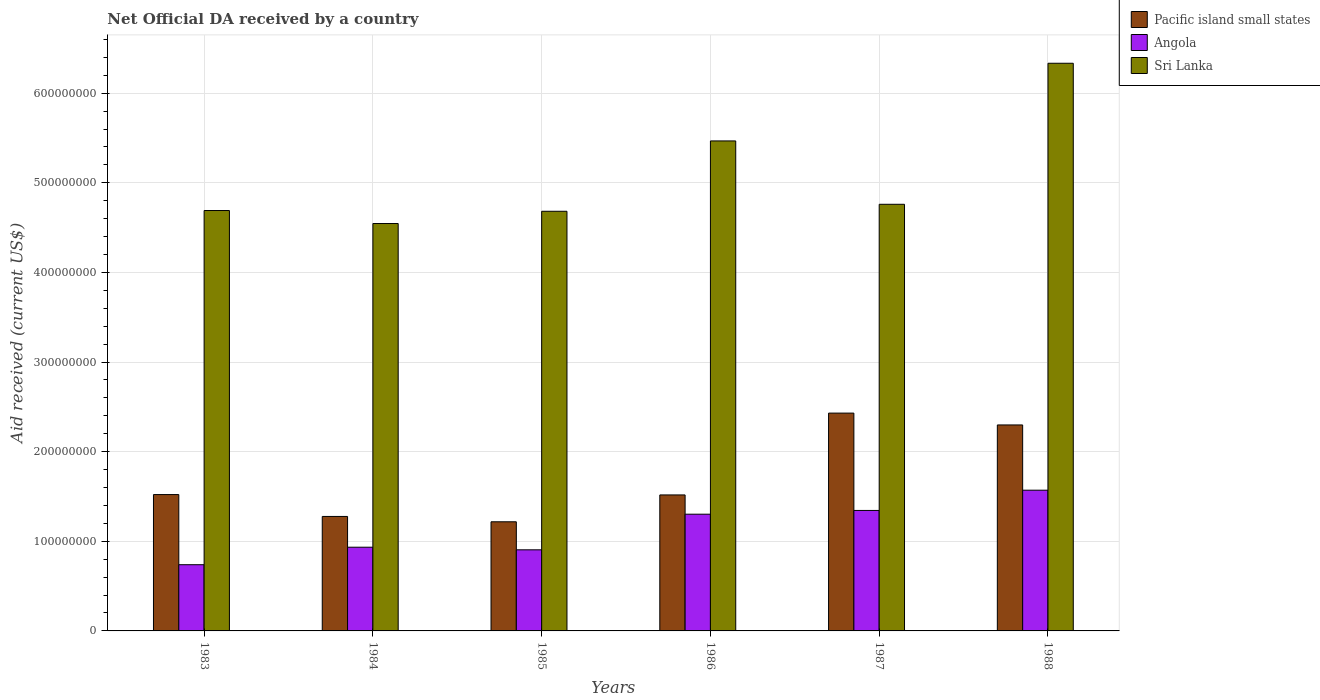How many groups of bars are there?
Ensure brevity in your answer.  6. Are the number of bars per tick equal to the number of legend labels?
Your answer should be very brief. Yes. Are the number of bars on each tick of the X-axis equal?
Provide a short and direct response. Yes. How many bars are there on the 3rd tick from the right?
Provide a succinct answer. 3. What is the label of the 2nd group of bars from the left?
Your answer should be very brief. 1984. What is the net official development assistance aid received in Angola in 1983?
Your response must be concise. 7.39e+07. Across all years, what is the maximum net official development assistance aid received in Angola?
Provide a succinct answer. 1.57e+08. Across all years, what is the minimum net official development assistance aid received in Sri Lanka?
Provide a succinct answer. 4.55e+08. In which year was the net official development assistance aid received in Sri Lanka minimum?
Offer a terse response. 1984. What is the total net official development assistance aid received in Sri Lanka in the graph?
Make the answer very short. 3.05e+09. What is the difference between the net official development assistance aid received in Sri Lanka in 1984 and that in 1987?
Give a very brief answer. -2.15e+07. What is the difference between the net official development assistance aid received in Sri Lanka in 1983 and the net official development assistance aid received in Pacific island small states in 1984?
Give a very brief answer. 3.41e+08. What is the average net official development assistance aid received in Angola per year?
Give a very brief answer. 1.13e+08. In the year 1985, what is the difference between the net official development assistance aid received in Pacific island small states and net official development assistance aid received in Angola?
Offer a terse response. 3.13e+07. In how many years, is the net official development assistance aid received in Angola greater than 300000000 US$?
Give a very brief answer. 0. What is the ratio of the net official development assistance aid received in Angola in 1985 to that in 1987?
Provide a succinct answer. 0.67. What is the difference between the highest and the second highest net official development assistance aid received in Angola?
Your answer should be very brief. 2.26e+07. What is the difference between the highest and the lowest net official development assistance aid received in Angola?
Your response must be concise. 8.32e+07. What does the 1st bar from the left in 1984 represents?
Your response must be concise. Pacific island small states. What does the 2nd bar from the right in 1984 represents?
Your answer should be very brief. Angola. Is it the case that in every year, the sum of the net official development assistance aid received in Angola and net official development assistance aid received in Sri Lanka is greater than the net official development assistance aid received in Pacific island small states?
Provide a succinct answer. Yes. Are all the bars in the graph horizontal?
Your response must be concise. No. How many years are there in the graph?
Keep it short and to the point. 6. What is the difference between two consecutive major ticks on the Y-axis?
Offer a terse response. 1.00e+08. Are the values on the major ticks of Y-axis written in scientific E-notation?
Your response must be concise. No. Does the graph contain grids?
Provide a short and direct response. Yes. How are the legend labels stacked?
Your answer should be compact. Vertical. What is the title of the graph?
Your response must be concise. Net Official DA received by a country. Does "South Asia" appear as one of the legend labels in the graph?
Provide a succinct answer. No. What is the label or title of the Y-axis?
Keep it short and to the point. Aid received (current US$). What is the Aid received (current US$) in Pacific island small states in 1983?
Offer a very short reply. 1.52e+08. What is the Aid received (current US$) of Angola in 1983?
Provide a short and direct response. 7.39e+07. What is the Aid received (current US$) in Sri Lanka in 1983?
Provide a short and direct response. 4.69e+08. What is the Aid received (current US$) in Pacific island small states in 1984?
Your answer should be very brief. 1.28e+08. What is the Aid received (current US$) of Angola in 1984?
Ensure brevity in your answer.  9.34e+07. What is the Aid received (current US$) in Sri Lanka in 1984?
Keep it short and to the point. 4.55e+08. What is the Aid received (current US$) in Pacific island small states in 1985?
Your response must be concise. 1.22e+08. What is the Aid received (current US$) in Angola in 1985?
Your answer should be compact. 9.05e+07. What is the Aid received (current US$) in Sri Lanka in 1985?
Ensure brevity in your answer.  4.68e+08. What is the Aid received (current US$) of Pacific island small states in 1986?
Offer a very short reply. 1.52e+08. What is the Aid received (current US$) in Angola in 1986?
Provide a succinct answer. 1.30e+08. What is the Aid received (current US$) of Sri Lanka in 1986?
Provide a succinct answer. 5.47e+08. What is the Aid received (current US$) of Pacific island small states in 1987?
Offer a terse response. 2.43e+08. What is the Aid received (current US$) in Angola in 1987?
Make the answer very short. 1.34e+08. What is the Aid received (current US$) of Sri Lanka in 1987?
Keep it short and to the point. 4.76e+08. What is the Aid received (current US$) in Pacific island small states in 1988?
Offer a terse response. 2.30e+08. What is the Aid received (current US$) of Angola in 1988?
Keep it short and to the point. 1.57e+08. What is the Aid received (current US$) in Sri Lanka in 1988?
Make the answer very short. 6.33e+08. Across all years, what is the maximum Aid received (current US$) of Pacific island small states?
Ensure brevity in your answer.  2.43e+08. Across all years, what is the maximum Aid received (current US$) in Angola?
Give a very brief answer. 1.57e+08. Across all years, what is the maximum Aid received (current US$) of Sri Lanka?
Keep it short and to the point. 6.33e+08. Across all years, what is the minimum Aid received (current US$) in Pacific island small states?
Offer a very short reply. 1.22e+08. Across all years, what is the minimum Aid received (current US$) in Angola?
Provide a short and direct response. 7.39e+07. Across all years, what is the minimum Aid received (current US$) of Sri Lanka?
Your answer should be compact. 4.55e+08. What is the total Aid received (current US$) of Pacific island small states in the graph?
Make the answer very short. 1.03e+09. What is the total Aid received (current US$) in Angola in the graph?
Offer a very short reply. 6.79e+08. What is the total Aid received (current US$) in Sri Lanka in the graph?
Offer a very short reply. 3.05e+09. What is the difference between the Aid received (current US$) of Pacific island small states in 1983 and that in 1984?
Ensure brevity in your answer.  2.44e+07. What is the difference between the Aid received (current US$) of Angola in 1983 and that in 1984?
Provide a short and direct response. -1.95e+07. What is the difference between the Aid received (current US$) in Sri Lanka in 1983 and that in 1984?
Provide a succinct answer. 1.45e+07. What is the difference between the Aid received (current US$) of Pacific island small states in 1983 and that in 1985?
Provide a short and direct response. 3.04e+07. What is the difference between the Aid received (current US$) in Angola in 1983 and that in 1985?
Give a very brief answer. -1.66e+07. What is the difference between the Aid received (current US$) of Sri Lanka in 1983 and that in 1985?
Give a very brief answer. 8.20e+05. What is the difference between the Aid received (current US$) of Angola in 1983 and that in 1986?
Your answer should be very brief. -5.64e+07. What is the difference between the Aid received (current US$) in Sri Lanka in 1983 and that in 1986?
Offer a terse response. -7.77e+07. What is the difference between the Aid received (current US$) in Pacific island small states in 1983 and that in 1987?
Your response must be concise. -9.09e+07. What is the difference between the Aid received (current US$) of Angola in 1983 and that in 1987?
Provide a succinct answer. -6.06e+07. What is the difference between the Aid received (current US$) in Sri Lanka in 1983 and that in 1987?
Offer a terse response. -6.97e+06. What is the difference between the Aid received (current US$) of Pacific island small states in 1983 and that in 1988?
Offer a very short reply. -7.77e+07. What is the difference between the Aid received (current US$) in Angola in 1983 and that in 1988?
Provide a succinct answer. -8.32e+07. What is the difference between the Aid received (current US$) of Sri Lanka in 1983 and that in 1988?
Your response must be concise. -1.64e+08. What is the difference between the Aid received (current US$) of Pacific island small states in 1984 and that in 1985?
Give a very brief answer. 5.96e+06. What is the difference between the Aid received (current US$) of Angola in 1984 and that in 1985?
Keep it short and to the point. 2.92e+06. What is the difference between the Aid received (current US$) in Sri Lanka in 1984 and that in 1985?
Give a very brief answer. -1.37e+07. What is the difference between the Aid received (current US$) of Pacific island small states in 1984 and that in 1986?
Your answer should be compact. -2.40e+07. What is the difference between the Aid received (current US$) in Angola in 1984 and that in 1986?
Offer a very short reply. -3.68e+07. What is the difference between the Aid received (current US$) in Sri Lanka in 1984 and that in 1986?
Your answer should be compact. -9.22e+07. What is the difference between the Aid received (current US$) in Pacific island small states in 1984 and that in 1987?
Give a very brief answer. -1.15e+08. What is the difference between the Aid received (current US$) in Angola in 1984 and that in 1987?
Your answer should be compact. -4.10e+07. What is the difference between the Aid received (current US$) in Sri Lanka in 1984 and that in 1987?
Keep it short and to the point. -2.15e+07. What is the difference between the Aid received (current US$) of Pacific island small states in 1984 and that in 1988?
Your answer should be very brief. -1.02e+08. What is the difference between the Aid received (current US$) in Angola in 1984 and that in 1988?
Your answer should be very brief. -6.36e+07. What is the difference between the Aid received (current US$) in Sri Lanka in 1984 and that in 1988?
Your answer should be very brief. -1.79e+08. What is the difference between the Aid received (current US$) in Pacific island small states in 1985 and that in 1986?
Offer a very short reply. -3.00e+07. What is the difference between the Aid received (current US$) of Angola in 1985 and that in 1986?
Ensure brevity in your answer.  -3.98e+07. What is the difference between the Aid received (current US$) of Sri Lanka in 1985 and that in 1986?
Give a very brief answer. -7.85e+07. What is the difference between the Aid received (current US$) in Pacific island small states in 1985 and that in 1987?
Offer a terse response. -1.21e+08. What is the difference between the Aid received (current US$) of Angola in 1985 and that in 1987?
Keep it short and to the point. -4.39e+07. What is the difference between the Aid received (current US$) in Sri Lanka in 1985 and that in 1987?
Make the answer very short. -7.79e+06. What is the difference between the Aid received (current US$) of Pacific island small states in 1985 and that in 1988?
Ensure brevity in your answer.  -1.08e+08. What is the difference between the Aid received (current US$) of Angola in 1985 and that in 1988?
Offer a terse response. -6.65e+07. What is the difference between the Aid received (current US$) in Sri Lanka in 1985 and that in 1988?
Keep it short and to the point. -1.65e+08. What is the difference between the Aid received (current US$) of Pacific island small states in 1986 and that in 1987?
Provide a short and direct response. -9.13e+07. What is the difference between the Aid received (current US$) in Angola in 1986 and that in 1987?
Your answer should be compact. -4.18e+06. What is the difference between the Aid received (current US$) of Sri Lanka in 1986 and that in 1987?
Ensure brevity in your answer.  7.07e+07. What is the difference between the Aid received (current US$) of Pacific island small states in 1986 and that in 1988?
Ensure brevity in your answer.  -7.81e+07. What is the difference between the Aid received (current US$) in Angola in 1986 and that in 1988?
Provide a short and direct response. -2.68e+07. What is the difference between the Aid received (current US$) of Sri Lanka in 1986 and that in 1988?
Offer a very short reply. -8.67e+07. What is the difference between the Aid received (current US$) of Pacific island small states in 1987 and that in 1988?
Provide a short and direct response. 1.32e+07. What is the difference between the Aid received (current US$) of Angola in 1987 and that in 1988?
Your answer should be compact. -2.26e+07. What is the difference between the Aid received (current US$) of Sri Lanka in 1987 and that in 1988?
Give a very brief answer. -1.57e+08. What is the difference between the Aid received (current US$) of Pacific island small states in 1983 and the Aid received (current US$) of Angola in 1984?
Your response must be concise. 5.87e+07. What is the difference between the Aid received (current US$) in Pacific island small states in 1983 and the Aid received (current US$) in Sri Lanka in 1984?
Give a very brief answer. -3.02e+08. What is the difference between the Aid received (current US$) in Angola in 1983 and the Aid received (current US$) in Sri Lanka in 1984?
Ensure brevity in your answer.  -3.81e+08. What is the difference between the Aid received (current US$) of Pacific island small states in 1983 and the Aid received (current US$) of Angola in 1985?
Make the answer very short. 6.17e+07. What is the difference between the Aid received (current US$) in Pacific island small states in 1983 and the Aid received (current US$) in Sri Lanka in 1985?
Keep it short and to the point. -3.16e+08. What is the difference between the Aid received (current US$) in Angola in 1983 and the Aid received (current US$) in Sri Lanka in 1985?
Provide a succinct answer. -3.94e+08. What is the difference between the Aid received (current US$) in Pacific island small states in 1983 and the Aid received (current US$) in Angola in 1986?
Your answer should be compact. 2.19e+07. What is the difference between the Aid received (current US$) of Pacific island small states in 1983 and the Aid received (current US$) of Sri Lanka in 1986?
Your answer should be very brief. -3.95e+08. What is the difference between the Aid received (current US$) of Angola in 1983 and the Aid received (current US$) of Sri Lanka in 1986?
Offer a very short reply. -4.73e+08. What is the difference between the Aid received (current US$) of Pacific island small states in 1983 and the Aid received (current US$) of Angola in 1987?
Offer a terse response. 1.77e+07. What is the difference between the Aid received (current US$) of Pacific island small states in 1983 and the Aid received (current US$) of Sri Lanka in 1987?
Provide a succinct answer. -3.24e+08. What is the difference between the Aid received (current US$) of Angola in 1983 and the Aid received (current US$) of Sri Lanka in 1987?
Keep it short and to the point. -4.02e+08. What is the difference between the Aid received (current US$) in Pacific island small states in 1983 and the Aid received (current US$) in Angola in 1988?
Offer a very short reply. -4.88e+06. What is the difference between the Aid received (current US$) of Pacific island small states in 1983 and the Aid received (current US$) of Sri Lanka in 1988?
Ensure brevity in your answer.  -4.81e+08. What is the difference between the Aid received (current US$) in Angola in 1983 and the Aid received (current US$) in Sri Lanka in 1988?
Provide a succinct answer. -5.60e+08. What is the difference between the Aid received (current US$) of Pacific island small states in 1984 and the Aid received (current US$) of Angola in 1985?
Provide a succinct answer. 3.72e+07. What is the difference between the Aid received (current US$) of Pacific island small states in 1984 and the Aid received (current US$) of Sri Lanka in 1985?
Offer a terse response. -3.41e+08. What is the difference between the Aid received (current US$) of Angola in 1984 and the Aid received (current US$) of Sri Lanka in 1985?
Give a very brief answer. -3.75e+08. What is the difference between the Aid received (current US$) of Pacific island small states in 1984 and the Aid received (current US$) of Angola in 1986?
Provide a short and direct response. -2.52e+06. What is the difference between the Aid received (current US$) in Pacific island small states in 1984 and the Aid received (current US$) in Sri Lanka in 1986?
Offer a terse response. -4.19e+08. What is the difference between the Aid received (current US$) of Angola in 1984 and the Aid received (current US$) of Sri Lanka in 1986?
Make the answer very short. -4.53e+08. What is the difference between the Aid received (current US$) of Pacific island small states in 1984 and the Aid received (current US$) of Angola in 1987?
Give a very brief answer. -6.70e+06. What is the difference between the Aid received (current US$) of Pacific island small states in 1984 and the Aid received (current US$) of Sri Lanka in 1987?
Offer a very short reply. -3.48e+08. What is the difference between the Aid received (current US$) of Angola in 1984 and the Aid received (current US$) of Sri Lanka in 1987?
Ensure brevity in your answer.  -3.83e+08. What is the difference between the Aid received (current US$) in Pacific island small states in 1984 and the Aid received (current US$) in Angola in 1988?
Provide a succinct answer. -2.93e+07. What is the difference between the Aid received (current US$) in Pacific island small states in 1984 and the Aid received (current US$) in Sri Lanka in 1988?
Ensure brevity in your answer.  -5.06e+08. What is the difference between the Aid received (current US$) of Angola in 1984 and the Aid received (current US$) of Sri Lanka in 1988?
Ensure brevity in your answer.  -5.40e+08. What is the difference between the Aid received (current US$) in Pacific island small states in 1985 and the Aid received (current US$) in Angola in 1986?
Your response must be concise. -8.48e+06. What is the difference between the Aid received (current US$) of Pacific island small states in 1985 and the Aid received (current US$) of Sri Lanka in 1986?
Give a very brief answer. -4.25e+08. What is the difference between the Aid received (current US$) in Angola in 1985 and the Aid received (current US$) in Sri Lanka in 1986?
Make the answer very short. -4.56e+08. What is the difference between the Aid received (current US$) of Pacific island small states in 1985 and the Aid received (current US$) of Angola in 1987?
Your response must be concise. -1.27e+07. What is the difference between the Aid received (current US$) in Pacific island small states in 1985 and the Aid received (current US$) in Sri Lanka in 1987?
Your answer should be compact. -3.54e+08. What is the difference between the Aid received (current US$) in Angola in 1985 and the Aid received (current US$) in Sri Lanka in 1987?
Offer a very short reply. -3.86e+08. What is the difference between the Aid received (current US$) of Pacific island small states in 1985 and the Aid received (current US$) of Angola in 1988?
Give a very brief answer. -3.53e+07. What is the difference between the Aid received (current US$) of Pacific island small states in 1985 and the Aid received (current US$) of Sri Lanka in 1988?
Your response must be concise. -5.12e+08. What is the difference between the Aid received (current US$) of Angola in 1985 and the Aid received (current US$) of Sri Lanka in 1988?
Provide a succinct answer. -5.43e+08. What is the difference between the Aid received (current US$) of Pacific island small states in 1986 and the Aid received (current US$) of Angola in 1987?
Make the answer very short. 1.73e+07. What is the difference between the Aid received (current US$) of Pacific island small states in 1986 and the Aid received (current US$) of Sri Lanka in 1987?
Keep it short and to the point. -3.24e+08. What is the difference between the Aid received (current US$) in Angola in 1986 and the Aid received (current US$) in Sri Lanka in 1987?
Give a very brief answer. -3.46e+08. What is the difference between the Aid received (current US$) in Pacific island small states in 1986 and the Aid received (current US$) in Angola in 1988?
Your answer should be compact. -5.29e+06. What is the difference between the Aid received (current US$) in Pacific island small states in 1986 and the Aid received (current US$) in Sri Lanka in 1988?
Offer a very short reply. -4.82e+08. What is the difference between the Aid received (current US$) of Angola in 1986 and the Aid received (current US$) of Sri Lanka in 1988?
Provide a short and direct response. -5.03e+08. What is the difference between the Aid received (current US$) of Pacific island small states in 1987 and the Aid received (current US$) of Angola in 1988?
Your response must be concise. 8.60e+07. What is the difference between the Aid received (current US$) of Pacific island small states in 1987 and the Aid received (current US$) of Sri Lanka in 1988?
Your answer should be very brief. -3.90e+08. What is the difference between the Aid received (current US$) in Angola in 1987 and the Aid received (current US$) in Sri Lanka in 1988?
Give a very brief answer. -4.99e+08. What is the average Aid received (current US$) in Pacific island small states per year?
Ensure brevity in your answer.  1.71e+08. What is the average Aid received (current US$) in Angola per year?
Keep it short and to the point. 1.13e+08. What is the average Aid received (current US$) in Sri Lanka per year?
Keep it short and to the point. 5.08e+08. In the year 1983, what is the difference between the Aid received (current US$) of Pacific island small states and Aid received (current US$) of Angola?
Provide a succinct answer. 7.83e+07. In the year 1983, what is the difference between the Aid received (current US$) of Pacific island small states and Aid received (current US$) of Sri Lanka?
Your response must be concise. -3.17e+08. In the year 1983, what is the difference between the Aid received (current US$) in Angola and Aid received (current US$) in Sri Lanka?
Ensure brevity in your answer.  -3.95e+08. In the year 1984, what is the difference between the Aid received (current US$) in Pacific island small states and Aid received (current US$) in Angola?
Make the answer very short. 3.43e+07. In the year 1984, what is the difference between the Aid received (current US$) in Pacific island small states and Aid received (current US$) in Sri Lanka?
Your answer should be very brief. -3.27e+08. In the year 1984, what is the difference between the Aid received (current US$) of Angola and Aid received (current US$) of Sri Lanka?
Your response must be concise. -3.61e+08. In the year 1985, what is the difference between the Aid received (current US$) of Pacific island small states and Aid received (current US$) of Angola?
Your response must be concise. 3.13e+07. In the year 1985, what is the difference between the Aid received (current US$) of Pacific island small states and Aid received (current US$) of Sri Lanka?
Offer a very short reply. -3.46e+08. In the year 1985, what is the difference between the Aid received (current US$) of Angola and Aid received (current US$) of Sri Lanka?
Offer a terse response. -3.78e+08. In the year 1986, what is the difference between the Aid received (current US$) of Pacific island small states and Aid received (current US$) of Angola?
Your response must be concise. 2.15e+07. In the year 1986, what is the difference between the Aid received (current US$) in Pacific island small states and Aid received (current US$) in Sri Lanka?
Offer a terse response. -3.95e+08. In the year 1986, what is the difference between the Aid received (current US$) of Angola and Aid received (current US$) of Sri Lanka?
Give a very brief answer. -4.16e+08. In the year 1987, what is the difference between the Aid received (current US$) of Pacific island small states and Aid received (current US$) of Angola?
Your answer should be very brief. 1.09e+08. In the year 1987, what is the difference between the Aid received (current US$) of Pacific island small states and Aid received (current US$) of Sri Lanka?
Your answer should be compact. -2.33e+08. In the year 1987, what is the difference between the Aid received (current US$) of Angola and Aid received (current US$) of Sri Lanka?
Give a very brief answer. -3.42e+08. In the year 1988, what is the difference between the Aid received (current US$) in Pacific island small states and Aid received (current US$) in Angola?
Give a very brief answer. 7.28e+07. In the year 1988, what is the difference between the Aid received (current US$) of Pacific island small states and Aid received (current US$) of Sri Lanka?
Make the answer very short. -4.04e+08. In the year 1988, what is the difference between the Aid received (current US$) in Angola and Aid received (current US$) in Sri Lanka?
Your answer should be compact. -4.76e+08. What is the ratio of the Aid received (current US$) in Pacific island small states in 1983 to that in 1984?
Offer a very short reply. 1.19. What is the ratio of the Aid received (current US$) of Angola in 1983 to that in 1984?
Offer a very short reply. 0.79. What is the ratio of the Aid received (current US$) of Sri Lanka in 1983 to that in 1984?
Provide a short and direct response. 1.03. What is the ratio of the Aid received (current US$) of Pacific island small states in 1983 to that in 1985?
Your response must be concise. 1.25. What is the ratio of the Aid received (current US$) in Angola in 1983 to that in 1985?
Offer a terse response. 0.82. What is the ratio of the Aid received (current US$) of Sri Lanka in 1983 to that in 1985?
Your answer should be compact. 1. What is the ratio of the Aid received (current US$) in Angola in 1983 to that in 1986?
Give a very brief answer. 0.57. What is the ratio of the Aid received (current US$) in Sri Lanka in 1983 to that in 1986?
Keep it short and to the point. 0.86. What is the ratio of the Aid received (current US$) of Pacific island small states in 1983 to that in 1987?
Offer a terse response. 0.63. What is the ratio of the Aid received (current US$) of Angola in 1983 to that in 1987?
Your answer should be compact. 0.55. What is the ratio of the Aid received (current US$) of Sri Lanka in 1983 to that in 1987?
Your answer should be very brief. 0.99. What is the ratio of the Aid received (current US$) of Pacific island small states in 1983 to that in 1988?
Keep it short and to the point. 0.66. What is the ratio of the Aid received (current US$) in Angola in 1983 to that in 1988?
Keep it short and to the point. 0.47. What is the ratio of the Aid received (current US$) in Sri Lanka in 1983 to that in 1988?
Make the answer very short. 0.74. What is the ratio of the Aid received (current US$) in Pacific island small states in 1984 to that in 1985?
Your answer should be very brief. 1.05. What is the ratio of the Aid received (current US$) of Angola in 1984 to that in 1985?
Offer a terse response. 1.03. What is the ratio of the Aid received (current US$) of Sri Lanka in 1984 to that in 1985?
Provide a succinct answer. 0.97. What is the ratio of the Aid received (current US$) in Pacific island small states in 1984 to that in 1986?
Offer a terse response. 0.84. What is the ratio of the Aid received (current US$) of Angola in 1984 to that in 1986?
Keep it short and to the point. 0.72. What is the ratio of the Aid received (current US$) in Sri Lanka in 1984 to that in 1986?
Ensure brevity in your answer.  0.83. What is the ratio of the Aid received (current US$) in Pacific island small states in 1984 to that in 1987?
Offer a very short reply. 0.53. What is the ratio of the Aid received (current US$) of Angola in 1984 to that in 1987?
Give a very brief answer. 0.69. What is the ratio of the Aid received (current US$) of Sri Lanka in 1984 to that in 1987?
Your response must be concise. 0.95. What is the ratio of the Aid received (current US$) of Pacific island small states in 1984 to that in 1988?
Provide a succinct answer. 0.56. What is the ratio of the Aid received (current US$) of Angola in 1984 to that in 1988?
Your answer should be compact. 0.59. What is the ratio of the Aid received (current US$) in Sri Lanka in 1984 to that in 1988?
Offer a very short reply. 0.72. What is the ratio of the Aid received (current US$) of Pacific island small states in 1985 to that in 1986?
Provide a succinct answer. 0.8. What is the ratio of the Aid received (current US$) in Angola in 1985 to that in 1986?
Your answer should be compact. 0.69. What is the ratio of the Aid received (current US$) of Sri Lanka in 1985 to that in 1986?
Give a very brief answer. 0.86. What is the ratio of the Aid received (current US$) of Pacific island small states in 1985 to that in 1987?
Offer a very short reply. 0.5. What is the ratio of the Aid received (current US$) in Angola in 1985 to that in 1987?
Offer a very short reply. 0.67. What is the ratio of the Aid received (current US$) of Sri Lanka in 1985 to that in 1987?
Provide a short and direct response. 0.98. What is the ratio of the Aid received (current US$) of Pacific island small states in 1985 to that in 1988?
Your response must be concise. 0.53. What is the ratio of the Aid received (current US$) of Angola in 1985 to that in 1988?
Your answer should be compact. 0.58. What is the ratio of the Aid received (current US$) of Sri Lanka in 1985 to that in 1988?
Provide a short and direct response. 0.74. What is the ratio of the Aid received (current US$) in Pacific island small states in 1986 to that in 1987?
Your answer should be very brief. 0.62. What is the ratio of the Aid received (current US$) in Angola in 1986 to that in 1987?
Your response must be concise. 0.97. What is the ratio of the Aid received (current US$) in Sri Lanka in 1986 to that in 1987?
Your answer should be compact. 1.15. What is the ratio of the Aid received (current US$) in Pacific island small states in 1986 to that in 1988?
Ensure brevity in your answer.  0.66. What is the ratio of the Aid received (current US$) in Angola in 1986 to that in 1988?
Provide a short and direct response. 0.83. What is the ratio of the Aid received (current US$) of Sri Lanka in 1986 to that in 1988?
Offer a terse response. 0.86. What is the ratio of the Aid received (current US$) of Pacific island small states in 1987 to that in 1988?
Make the answer very short. 1.06. What is the ratio of the Aid received (current US$) of Angola in 1987 to that in 1988?
Offer a terse response. 0.86. What is the ratio of the Aid received (current US$) of Sri Lanka in 1987 to that in 1988?
Your answer should be very brief. 0.75. What is the difference between the highest and the second highest Aid received (current US$) of Pacific island small states?
Provide a succinct answer. 1.32e+07. What is the difference between the highest and the second highest Aid received (current US$) of Angola?
Your response must be concise. 2.26e+07. What is the difference between the highest and the second highest Aid received (current US$) of Sri Lanka?
Give a very brief answer. 8.67e+07. What is the difference between the highest and the lowest Aid received (current US$) in Pacific island small states?
Offer a terse response. 1.21e+08. What is the difference between the highest and the lowest Aid received (current US$) in Angola?
Offer a very short reply. 8.32e+07. What is the difference between the highest and the lowest Aid received (current US$) of Sri Lanka?
Offer a very short reply. 1.79e+08. 